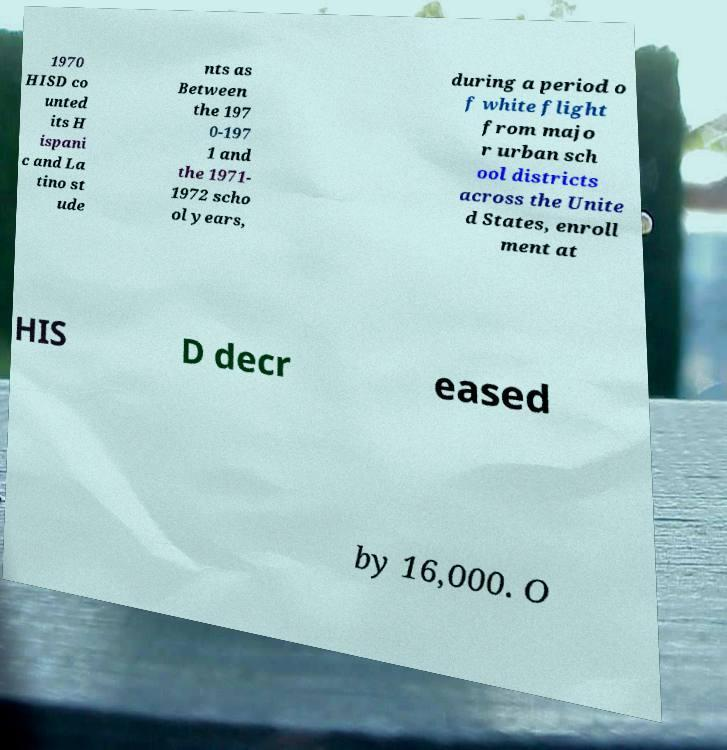Can you accurately transcribe the text from the provided image for me? 1970 HISD co unted its H ispani c and La tino st ude nts as Between the 197 0-197 1 and the 1971- 1972 scho ol years, during a period o f white flight from majo r urban sch ool districts across the Unite d States, enroll ment at HIS D decr eased by 16,000. O 